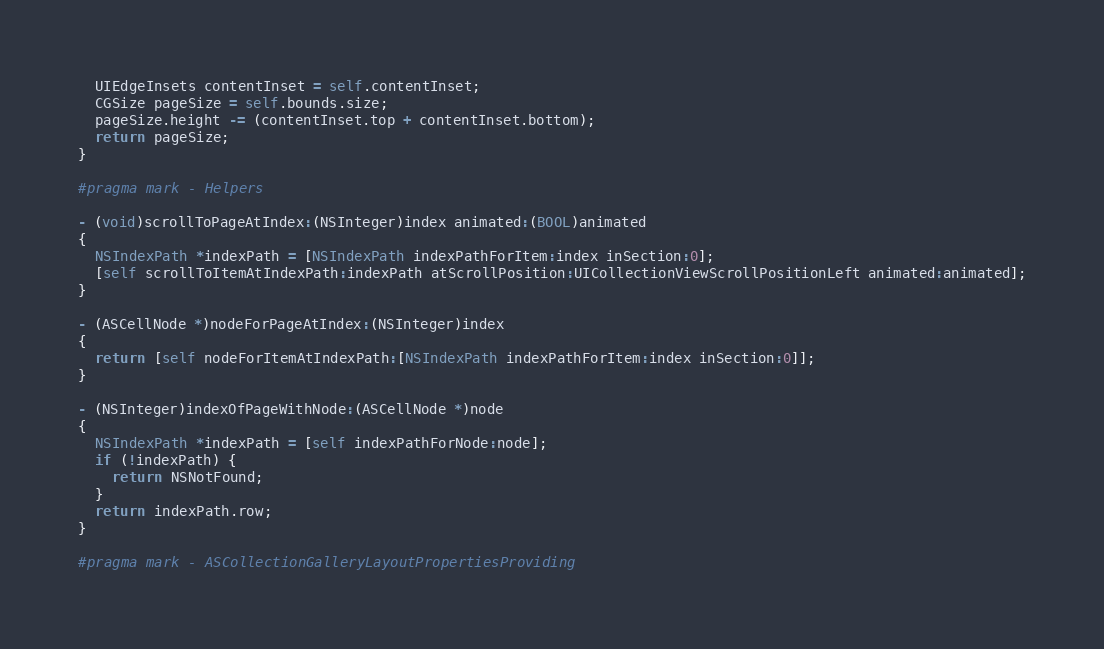Convert code to text. <code><loc_0><loc_0><loc_500><loc_500><_ObjectiveC_>  UIEdgeInsets contentInset = self.contentInset;
  CGSize pageSize = self.bounds.size;
  pageSize.height -= (contentInset.top + contentInset.bottom);
  return pageSize;
}

#pragma mark - Helpers

- (void)scrollToPageAtIndex:(NSInteger)index animated:(BOOL)animated
{
  NSIndexPath *indexPath = [NSIndexPath indexPathForItem:index inSection:0];
  [self scrollToItemAtIndexPath:indexPath atScrollPosition:UICollectionViewScrollPositionLeft animated:animated];
}

- (ASCellNode *)nodeForPageAtIndex:(NSInteger)index
{
  return [self nodeForItemAtIndexPath:[NSIndexPath indexPathForItem:index inSection:0]];
}

- (NSInteger)indexOfPageWithNode:(ASCellNode *)node
{
  NSIndexPath *indexPath = [self indexPathForNode:node];
  if (!indexPath) {
    return NSNotFound;
  }
  return indexPath.row;
}

#pragma mark - ASCollectionGalleryLayoutPropertiesProviding
</code> 